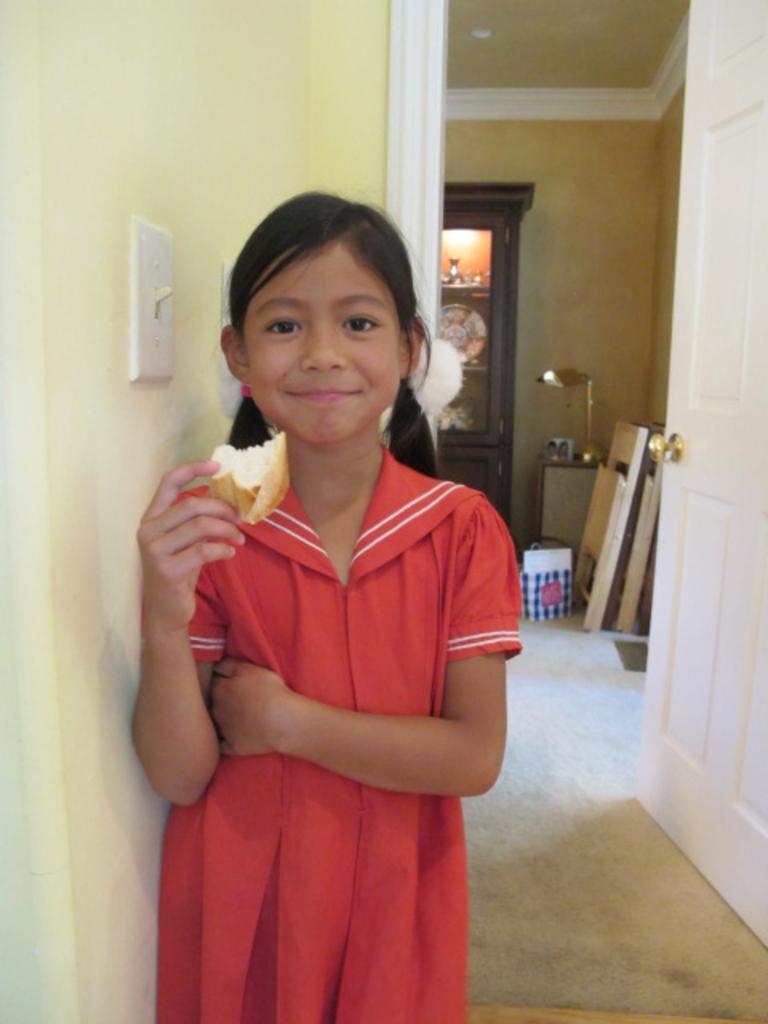Please provide a concise description of this image. In the middle of the image we can see a girl, she is holding a bread and she is smiling, behind her we can see a bag, lights and few things in the racks. 